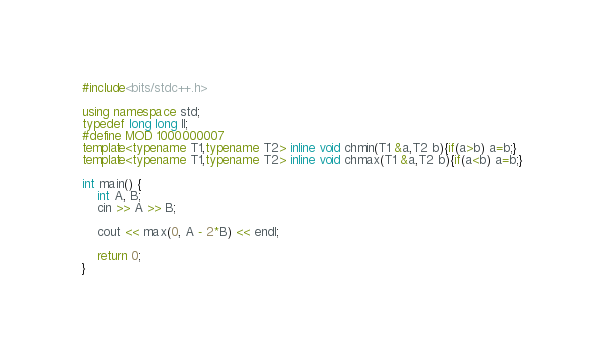Convert code to text. <code><loc_0><loc_0><loc_500><loc_500><_C++_>#include<bits/stdc++.h>

using namespace std;
typedef long long ll;
#define MOD 1000000007
template<typename T1,typename T2> inline void chmin(T1 &a,T2 b){if(a>b) a=b;}
template<typename T1,typename T2> inline void chmax(T1 &a,T2 b){if(a<b) a=b;}

int main() {
    int A, B;
    cin >> A >> B;
    
    cout << max(0, A - 2*B) << endl;

    return 0;
}</code> 